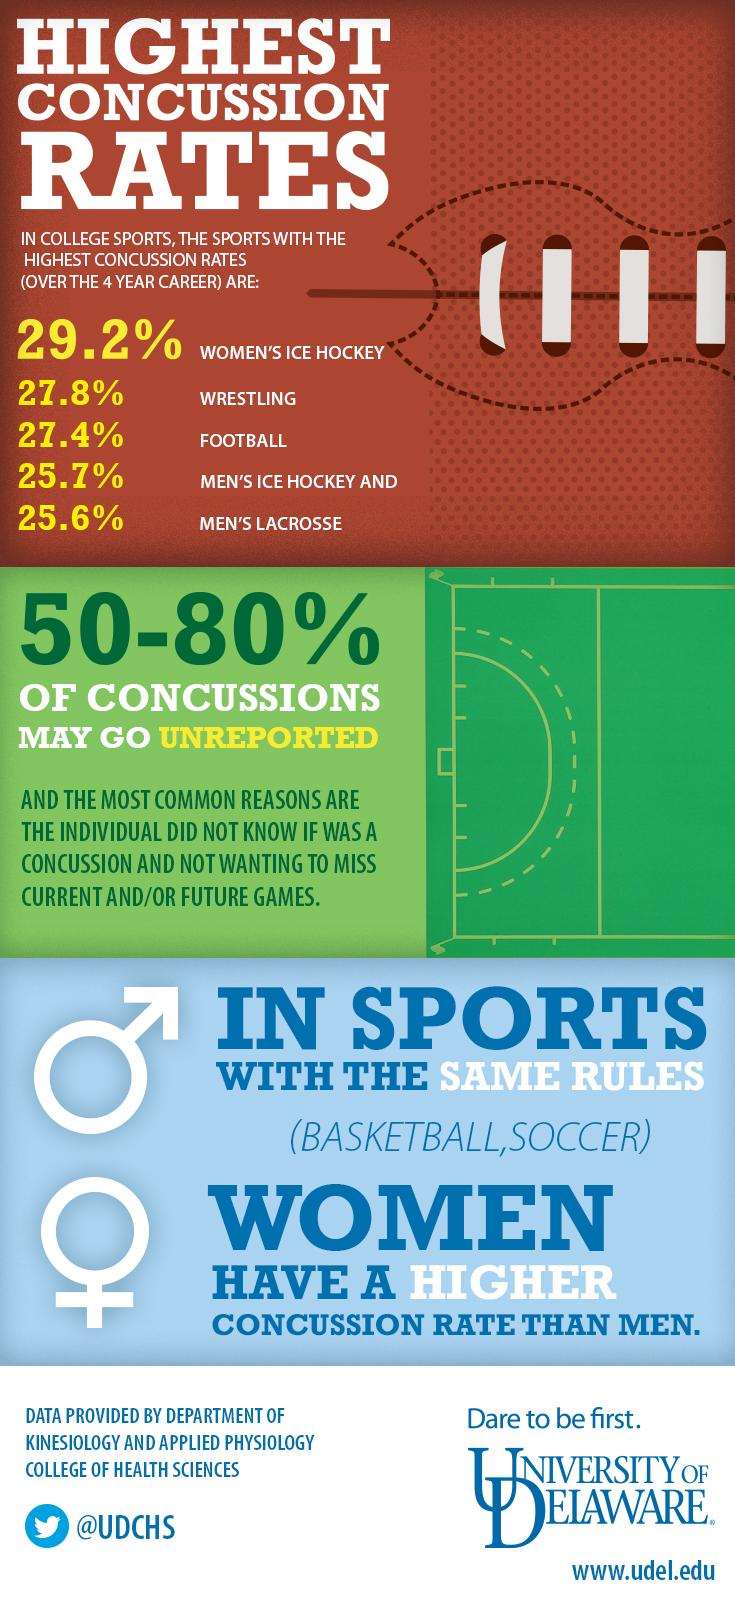Draw attention to some important aspects in this diagram. The Twitter handle given is @UDCHS. In ice hockey, women have a higher concussion rate compared to men. In sports with identical regulations, it has been found that female athletes have a lower incidence of concussions compared to male athletes. 